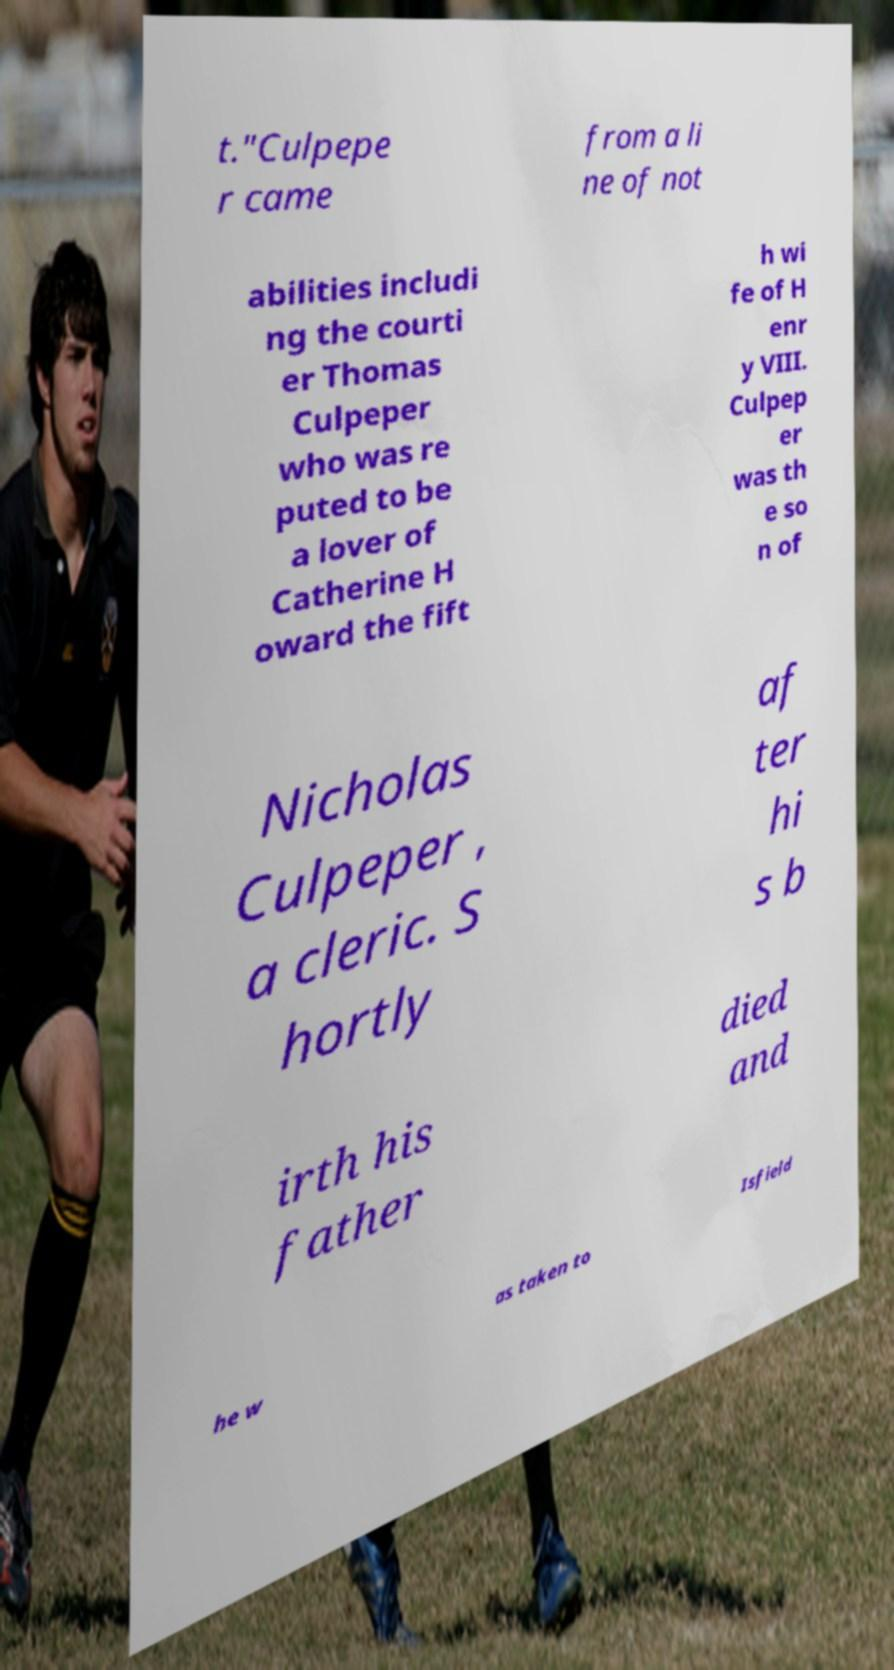I need the written content from this picture converted into text. Can you do that? t."Culpepe r came from a li ne of not abilities includi ng the courti er Thomas Culpeper who was re puted to be a lover of Catherine H oward the fift h wi fe of H enr y VIII. Culpep er was th e so n of Nicholas Culpeper , a cleric. S hortly af ter hi s b irth his father died and he w as taken to Isfield 